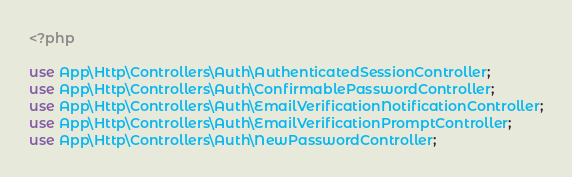Convert code to text. <code><loc_0><loc_0><loc_500><loc_500><_PHP_><?php

use App\Http\Controllers\Auth\AuthenticatedSessionController;
use App\Http\Controllers\Auth\ConfirmablePasswordController;
use App\Http\Controllers\Auth\EmailVerificationNotificationController;
use App\Http\Controllers\Auth\EmailVerificationPromptController;
use App\Http\Controllers\Auth\NewPasswordController;</code> 